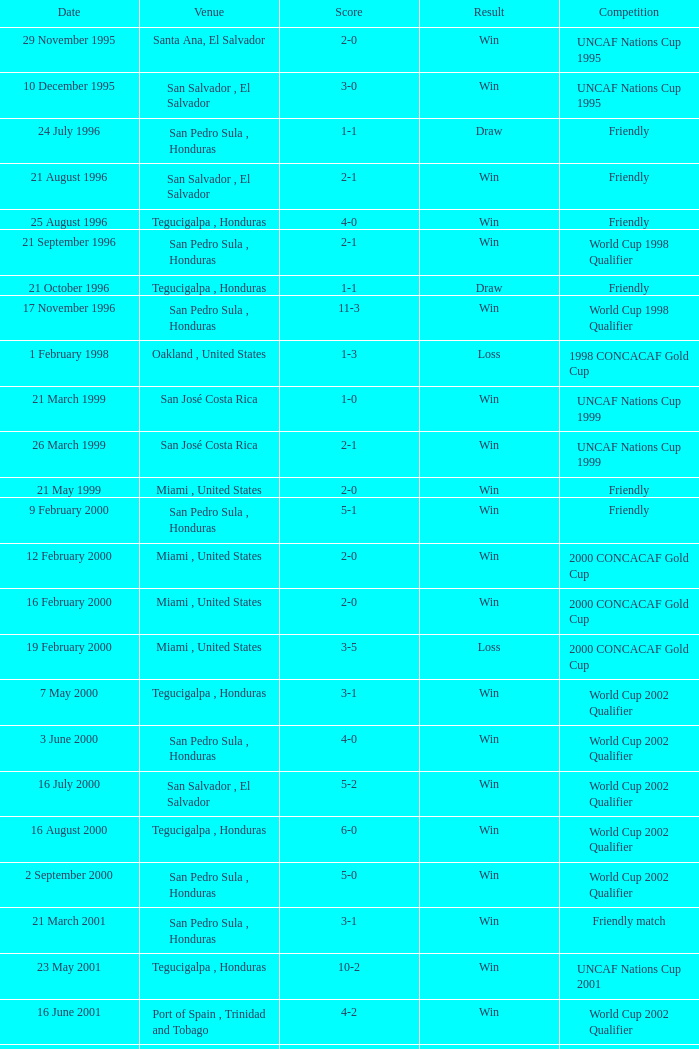Which place hosted the friendly contest that ended in a 4-0 result? Tegucigalpa , Honduras. 